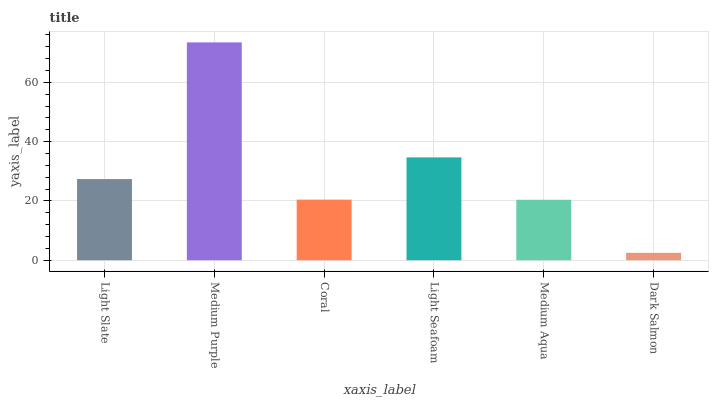Is Dark Salmon the minimum?
Answer yes or no. Yes. Is Medium Purple the maximum?
Answer yes or no. Yes. Is Coral the minimum?
Answer yes or no. No. Is Coral the maximum?
Answer yes or no. No. Is Medium Purple greater than Coral?
Answer yes or no. Yes. Is Coral less than Medium Purple?
Answer yes or no. Yes. Is Coral greater than Medium Purple?
Answer yes or no. No. Is Medium Purple less than Coral?
Answer yes or no. No. Is Light Slate the high median?
Answer yes or no. Yes. Is Coral the low median?
Answer yes or no. Yes. Is Medium Aqua the high median?
Answer yes or no. No. Is Light Slate the low median?
Answer yes or no. No. 